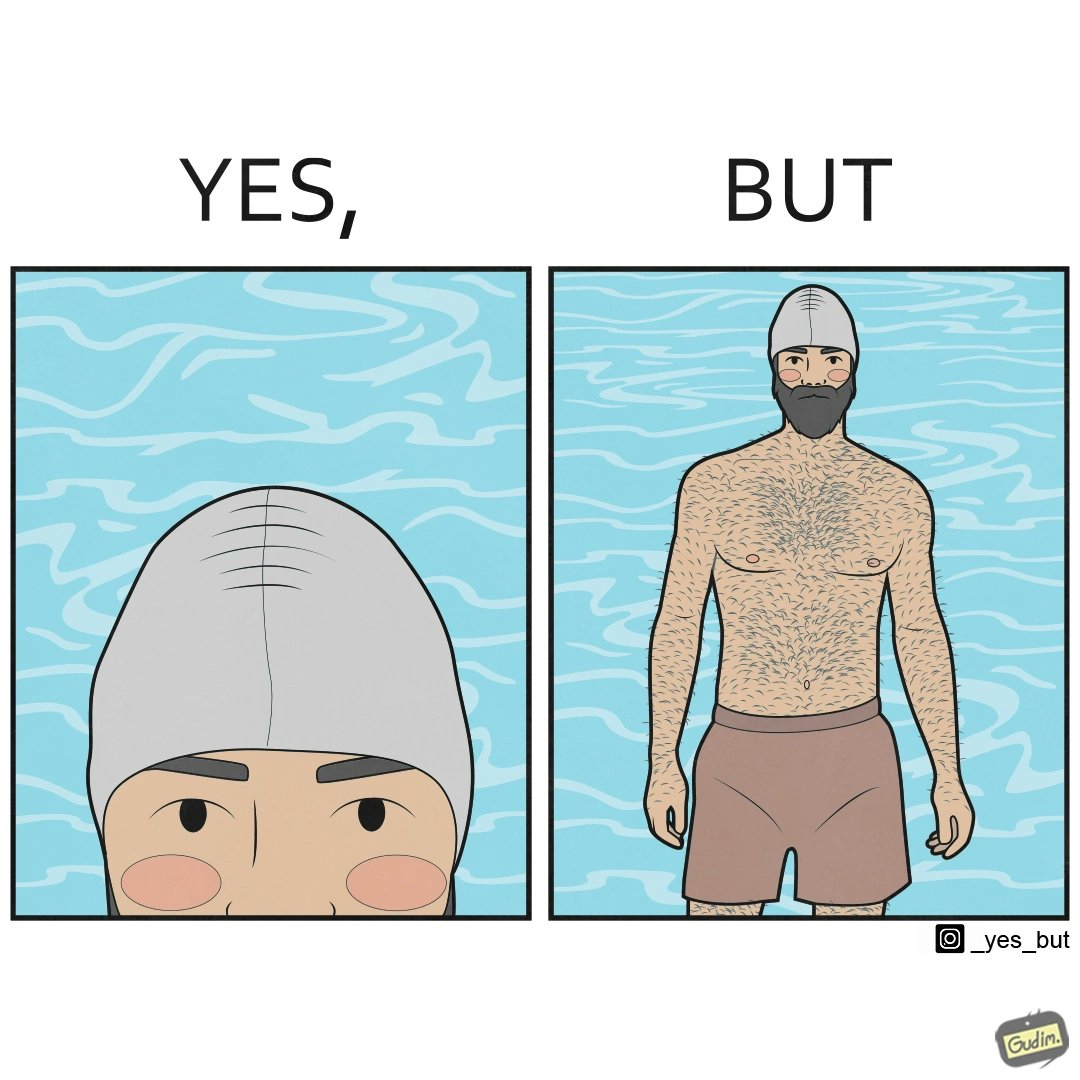Is there satirical content in this image? Yes, this image is satirical. 